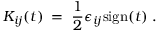<formula> <loc_0><loc_0><loc_500><loc_500>K _ { i j } ( t ) \, = \, \frac { 1 } { 2 } \epsilon _ { i j } s i g n ( t ) \, .</formula> 